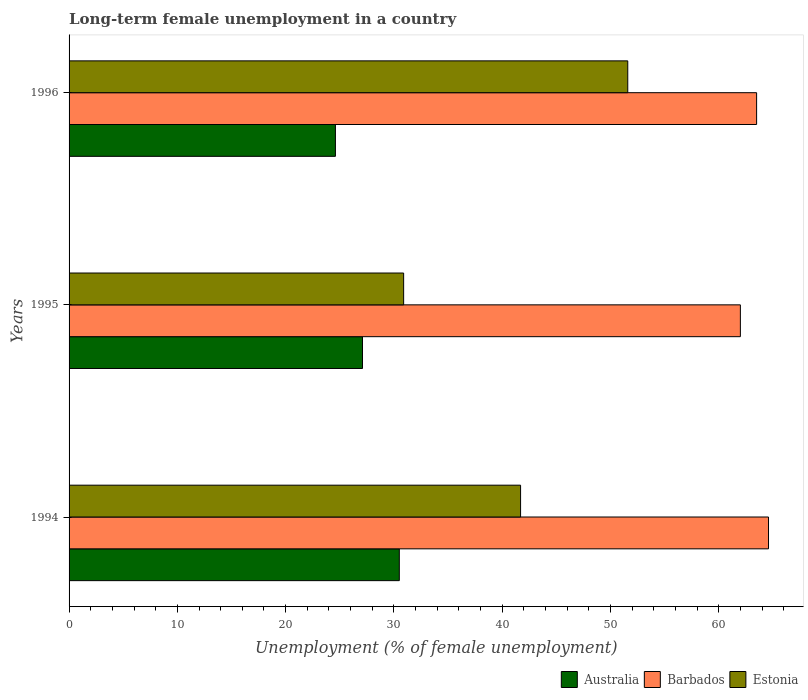How many groups of bars are there?
Your response must be concise. 3. Are the number of bars per tick equal to the number of legend labels?
Provide a short and direct response. Yes. How many bars are there on the 1st tick from the bottom?
Your answer should be very brief. 3. What is the label of the 2nd group of bars from the top?
Offer a very short reply. 1995. In how many cases, is the number of bars for a given year not equal to the number of legend labels?
Your answer should be compact. 0. What is the percentage of long-term unemployed female population in Barbados in 1995?
Your answer should be compact. 62. Across all years, what is the maximum percentage of long-term unemployed female population in Barbados?
Provide a short and direct response. 64.6. Across all years, what is the minimum percentage of long-term unemployed female population in Estonia?
Your response must be concise. 30.9. In which year was the percentage of long-term unemployed female population in Australia maximum?
Provide a short and direct response. 1994. What is the total percentage of long-term unemployed female population in Australia in the graph?
Your answer should be compact. 82.2. What is the difference between the percentage of long-term unemployed female population in Barbados in 1994 and that in 1996?
Your answer should be compact. 1.1. What is the difference between the percentage of long-term unemployed female population in Estonia in 1994 and the percentage of long-term unemployed female population in Barbados in 1996?
Provide a short and direct response. -21.8. What is the average percentage of long-term unemployed female population in Barbados per year?
Your response must be concise. 63.37. In the year 1995, what is the difference between the percentage of long-term unemployed female population in Estonia and percentage of long-term unemployed female population in Barbados?
Your answer should be compact. -31.1. What is the ratio of the percentage of long-term unemployed female population in Barbados in 1994 to that in 1995?
Offer a terse response. 1.04. Is the percentage of long-term unemployed female population in Barbados in 1995 less than that in 1996?
Ensure brevity in your answer.  Yes. What is the difference between the highest and the second highest percentage of long-term unemployed female population in Barbados?
Provide a succinct answer. 1.1. What is the difference between the highest and the lowest percentage of long-term unemployed female population in Australia?
Make the answer very short. 5.9. In how many years, is the percentage of long-term unemployed female population in Barbados greater than the average percentage of long-term unemployed female population in Barbados taken over all years?
Your answer should be very brief. 2. What does the 1st bar from the top in 1994 represents?
Provide a succinct answer. Estonia. What does the 2nd bar from the bottom in 1996 represents?
Your response must be concise. Barbados. Is it the case that in every year, the sum of the percentage of long-term unemployed female population in Barbados and percentage of long-term unemployed female population in Australia is greater than the percentage of long-term unemployed female population in Estonia?
Keep it short and to the point. Yes. How many bars are there?
Make the answer very short. 9. Are the values on the major ticks of X-axis written in scientific E-notation?
Provide a succinct answer. No. What is the title of the graph?
Offer a terse response. Long-term female unemployment in a country. Does "Netherlands" appear as one of the legend labels in the graph?
Offer a terse response. No. What is the label or title of the X-axis?
Your answer should be compact. Unemployment (% of female unemployment). What is the Unemployment (% of female unemployment) in Australia in 1994?
Ensure brevity in your answer.  30.5. What is the Unemployment (% of female unemployment) of Barbados in 1994?
Your answer should be compact. 64.6. What is the Unemployment (% of female unemployment) of Estonia in 1994?
Offer a terse response. 41.7. What is the Unemployment (% of female unemployment) of Australia in 1995?
Make the answer very short. 27.1. What is the Unemployment (% of female unemployment) in Estonia in 1995?
Your response must be concise. 30.9. What is the Unemployment (% of female unemployment) in Australia in 1996?
Provide a succinct answer. 24.6. What is the Unemployment (% of female unemployment) of Barbados in 1996?
Make the answer very short. 63.5. What is the Unemployment (% of female unemployment) in Estonia in 1996?
Ensure brevity in your answer.  51.6. Across all years, what is the maximum Unemployment (% of female unemployment) in Australia?
Keep it short and to the point. 30.5. Across all years, what is the maximum Unemployment (% of female unemployment) of Barbados?
Your answer should be compact. 64.6. Across all years, what is the maximum Unemployment (% of female unemployment) of Estonia?
Provide a short and direct response. 51.6. Across all years, what is the minimum Unemployment (% of female unemployment) in Australia?
Your answer should be compact. 24.6. Across all years, what is the minimum Unemployment (% of female unemployment) of Estonia?
Your answer should be compact. 30.9. What is the total Unemployment (% of female unemployment) in Australia in the graph?
Your response must be concise. 82.2. What is the total Unemployment (% of female unemployment) in Barbados in the graph?
Your answer should be compact. 190.1. What is the total Unemployment (% of female unemployment) in Estonia in the graph?
Offer a very short reply. 124.2. What is the difference between the Unemployment (% of female unemployment) in Barbados in 1994 and that in 1996?
Provide a short and direct response. 1.1. What is the difference between the Unemployment (% of female unemployment) of Estonia in 1994 and that in 1996?
Offer a very short reply. -9.9. What is the difference between the Unemployment (% of female unemployment) in Australia in 1995 and that in 1996?
Provide a short and direct response. 2.5. What is the difference between the Unemployment (% of female unemployment) of Barbados in 1995 and that in 1996?
Provide a short and direct response. -1.5. What is the difference between the Unemployment (% of female unemployment) in Estonia in 1995 and that in 1996?
Your response must be concise. -20.7. What is the difference between the Unemployment (% of female unemployment) of Australia in 1994 and the Unemployment (% of female unemployment) of Barbados in 1995?
Make the answer very short. -31.5. What is the difference between the Unemployment (% of female unemployment) of Australia in 1994 and the Unemployment (% of female unemployment) of Estonia in 1995?
Your answer should be very brief. -0.4. What is the difference between the Unemployment (% of female unemployment) of Barbados in 1994 and the Unemployment (% of female unemployment) of Estonia in 1995?
Your answer should be very brief. 33.7. What is the difference between the Unemployment (% of female unemployment) of Australia in 1994 and the Unemployment (% of female unemployment) of Barbados in 1996?
Offer a terse response. -33. What is the difference between the Unemployment (% of female unemployment) in Australia in 1994 and the Unemployment (% of female unemployment) in Estonia in 1996?
Give a very brief answer. -21.1. What is the difference between the Unemployment (% of female unemployment) of Barbados in 1994 and the Unemployment (% of female unemployment) of Estonia in 1996?
Give a very brief answer. 13. What is the difference between the Unemployment (% of female unemployment) of Australia in 1995 and the Unemployment (% of female unemployment) of Barbados in 1996?
Keep it short and to the point. -36.4. What is the difference between the Unemployment (% of female unemployment) of Australia in 1995 and the Unemployment (% of female unemployment) of Estonia in 1996?
Offer a terse response. -24.5. What is the average Unemployment (% of female unemployment) of Australia per year?
Ensure brevity in your answer.  27.4. What is the average Unemployment (% of female unemployment) in Barbados per year?
Your response must be concise. 63.37. What is the average Unemployment (% of female unemployment) of Estonia per year?
Make the answer very short. 41.4. In the year 1994, what is the difference between the Unemployment (% of female unemployment) of Australia and Unemployment (% of female unemployment) of Barbados?
Offer a terse response. -34.1. In the year 1994, what is the difference between the Unemployment (% of female unemployment) in Barbados and Unemployment (% of female unemployment) in Estonia?
Make the answer very short. 22.9. In the year 1995, what is the difference between the Unemployment (% of female unemployment) in Australia and Unemployment (% of female unemployment) in Barbados?
Ensure brevity in your answer.  -34.9. In the year 1995, what is the difference between the Unemployment (% of female unemployment) in Australia and Unemployment (% of female unemployment) in Estonia?
Your answer should be compact. -3.8. In the year 1995, what is the difference between the Unemployment (% of female unemployment) in Barbados and Unemployment (% of female unemployment) in Estonia?
Provide a succinct answer. 31.1. In the year 1996, what is the difference between the Unemployment (% of female unemployment) of Australia and Unemployment (% of female unemployment) of Barbados?
Your response must be concise. -38.9. In the year 1996, what is the difference between the Unemployment (% of female unemployment) in Australia and Unemployment (% of female unemployment) in Estonia?
Your answer should be compact. -27. What is the ratio of the Unemployment (% of female unemployment) of Australia in 1994 to that in 1995?
Offer a very short reply. 1.13. What is the ratio of the Unemployment (% of female unemployment) of Barbados in 1994 to that in 1995?
Provide a succinct answer. 1.04. What is the ratio of the Unemployment (% of female unemployment) of Estonia in 1994 to that in 1995?
Provide a succinct answer. 1.35. What is the ratio of the Unemployment (% of female unemployment) in Australia in 1994 to that in 1996?
Your response must be concise. 1.24. What is the ratio of the Unemployment (% of female unemployment) in Barbados in 1994 to that in 1996?
Offer a very short reply. 1.02. What is the ratio of the Unemployment (% of female unemployment) of Estonia in 1994 to that in 1996?
Your answer should be very brief. 0.81. What is the ratio of the Unemployment (% of female unemployment) in Australia in 1995 to that in 1996?
Give a very brief answer. 1.1. What is the ratio of the Unemployment (% of female unemployment) in Barbados in 1995 to that in 1996?
Your answer should be very brief. 0.98. What is the ratio of the Unemployment (% of female unemployment) of Estonia in 1995 to that in 1996?
Your answer should be very brief. 0.6. What is the difference between the highest and the second highest Unemployment (% of female unemployment) of Australia?
Provide a succinct answer. 3.4. What is the difference between the highest and the lowest Unemployment (% of female unemployment) in Australia?
Make the answer very short. 5.9. What is the difference between the highest and the lowest Unemployment (% of female unemployment) of Barbados?
Keep it short and to the point. 2.6. What is the difference between the highest and the lowest Unemployment (% of female unemployment) in Estonia?
Provide a short and direct response. 20.7. 